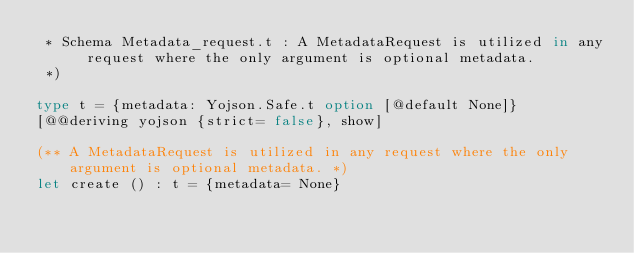Convert code to text. <code><loc_0><loc_0><loc_500><loc_500><_OCaml_> * Schema Metadata_request.t : A MetadataRequest is utilized in any request where the only argument is optional metadata.
 *)

type t = {metadata: Yojson.Safe.t option [@default None]}
[@@deriving yojson {strict= false}, show]

(** A MetadataRequest is utilized in any request where the only argument is optional metadata. *)
let create () : t = {metadata= None}
</code> 